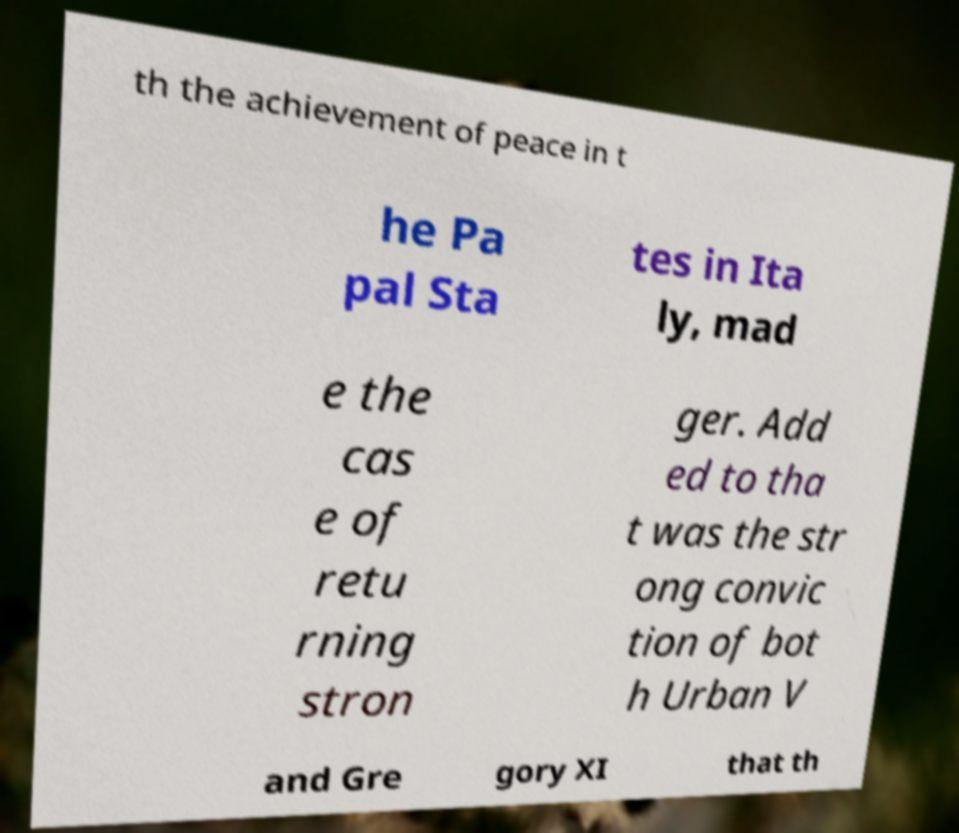Could you extract and type out the text from this image? th the achievement of peace in t he Pa pal Sta tes in Ita ly, mad e the cas e of retu rning stron ger. Add ed to tha t was the str ong convic tion of bot h Urban V and Gre gory XI that th 